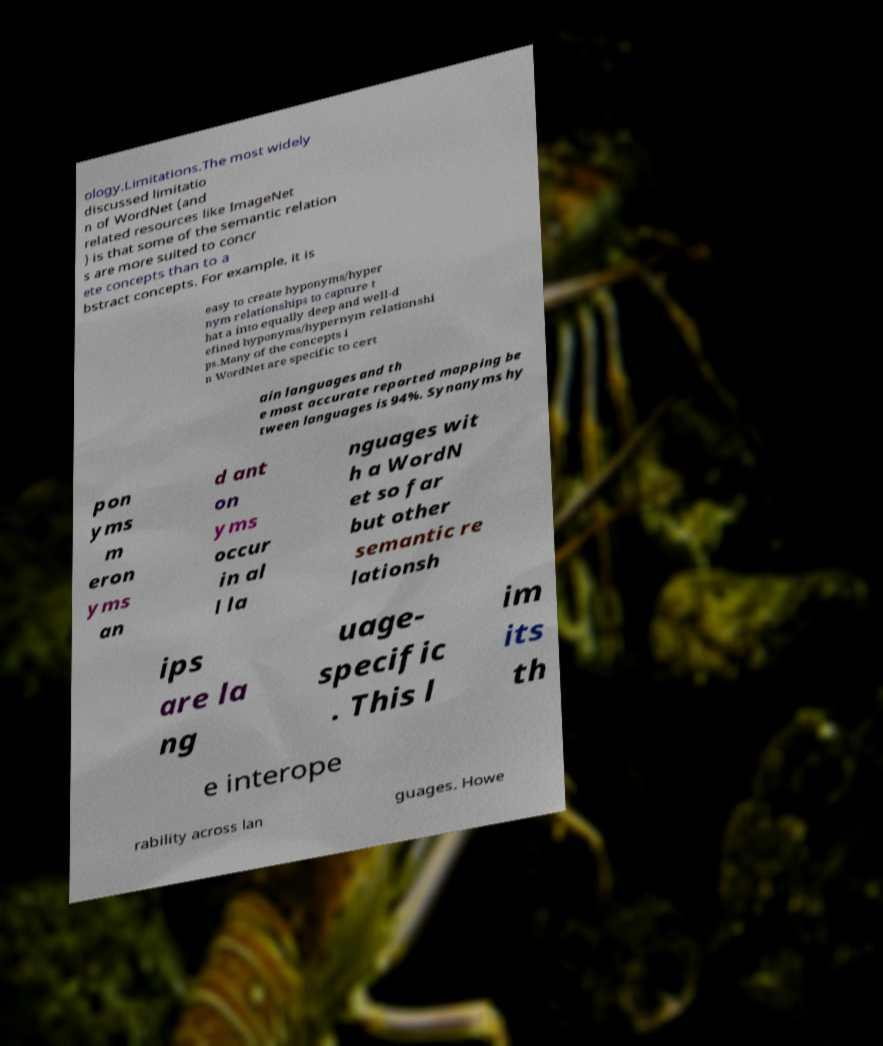What messages or text are displayed in this image? I need them in a readable, typed format. ology.Limitations.The most widely discussed limitatio n of WordNet (and related resources like ImageNet ) is that some of the semantic relation s are more suited to concr ete concepts than to a bstract concepts. For example, it is easy to create hyponyms/hyper nym relationships to capture t hat a into equally deep and well-d efined hyponyms/hypernym relationshi ps.Many of the concepts i n WordNet are specific to cert ain languages and th e most accurate reported mapping be tween languages is 94%. Synonyms hy pon yms m eron yms an d ant on yms occur in al l la nguages wit h a WordN et so far but other semantic re lationsh ips are la ng uage- specific . This l im its th e interope rability across lan guages. Howe 